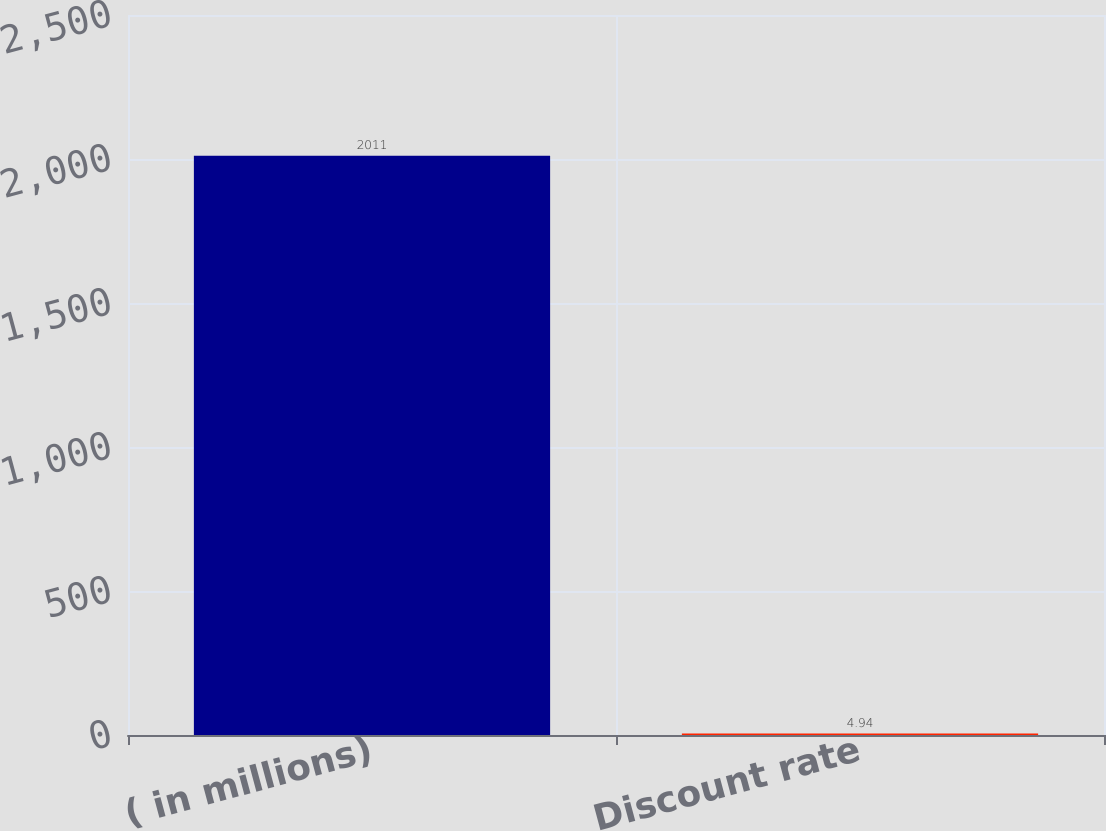Convert chart to OTSL. <chart><loc_0><loc_0><loc_500><loc_500><bar_chart><fcel>( in millions)<fcel>Discount rate<nl><fcel>2011<fcel>4.94<nl></chart> 